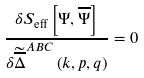Convert formula to latex. <formula><loc_0><loc_0><loc_500><loc_500>\frac { \delta S _ { \text {eff} } \left [ \Psi , \overline { \Psi } \right ] } { \delta \widetilde { \overline { \Delta } } ^ { A B C } \left ( k , p , q \right ) } = 0</formula> 